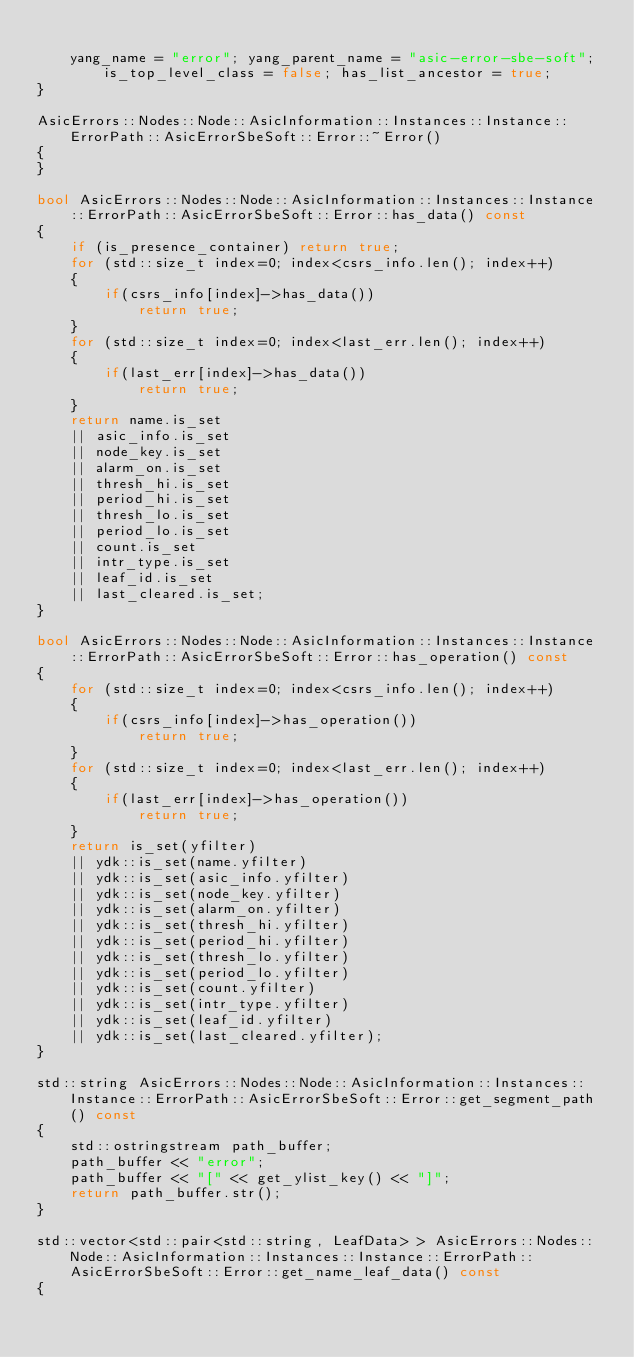Convert code to text. <code><loc_0><loc_0><loc_500><loc_500><_C++_>
    yang_name = "error"; yang_parent_name = "asic-error-sbe-soft"; is_top_level_class = false; has_list_ancestor = true; 
}

AsicErrors::Nodes::Node::AsicInformation::Instances::Instance::ErrorPath::AsicErrorSbeSoft::Error::~Error()
{
}

bool AsicErrors::Nodes::Node::AsicInformation::Instances::Instance::ErrorPath::AsicErrorSbeSoft::Error::has_data() const
{
    if (is_presence_container) return true;
    for (std::size_t index=0; index<csrs_info.len(); index++)
    {
        if(csrs_info[index]->has_data())
            return true;
    }
    for (std::size_t index=0; index<last_err.len(); index++)
    {
        if(last_err[index]->has_data())
            return true;
    }
    return name.is_set
	|| asic_info.is_set
	|| node_key.is_set
	|| alarm_on.is_set
	|| thresh_hi.is_set
	|| period_hi.is_set
	|| thresh_lo.is_set
	|| period_lo.is_set
	|| count.is_set
	|| intr_type.is_set
	|| leaf_id.is_set
	|| last_cleared.is_set;
}

bool AsicErrors::Nodes::Node::AsicInformation::Instances::Instance::ErrorPath::AsicErrorSbeSoft::Error::has_operation() const
{
    for (std::size_t index=0; index<csrs_info.len(); index++)
    {
        if(csrs_info[index]->has_operation())
            return true;
    }
    for (std::size_t index=0; index<last_err.len(); index++)
    {
        if(last_err[index]->has_operation())
            return true;
    }
    return is_set(yfilter)
	|| ydk::is_set(name.yfilter)
	|| ydk::is_set(asic_info.yfilter)
	|| ydk::is_set(node_key.yfilter)
	|| ydk::is_set(alarm_on.yfilter)
	|| ydk::is_set(thresh_hi.yfilter)
	|| ydk::is_set(period_hi.yfilter)
	|| ydk::is_set(thresh_lo.yfilter)
	|| ydk::is_set(period_lo.yfilter)
	|| ydk::is_set(count.yfilter)
	|| ydk::is_set(intr_type.yfilter)
	|| ydk::is_set(leaf_id.yfilter)
	|| ydk::is_set(last_cleared.yfilter);
}

std::string AsicErrors::Nodes::Node::AsicInformation::Instances::Instance::ErrorPath::AsicErrorSbeSoft::Error::get_segment_path() const
{
    std::ostringstream path_buffer;
    path_buffer << "error";
    path_buffer << "[" << get_ylist_key() << "]";
    return path_buffer.str();
}

std::vector<std::pair<std::string, LeafData> > AsicErrors::Nodes::Node::AsicInformation::Instances::Instance::ErrorPath::AsicErrorSbeSoft::Error::get_name_leaf_data() const
{</code> 